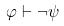<formula> <loc_0><loc_0><loc_500><loc_500>\varphi \vdash \neg \psi</formula> 